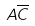Convert formula to latex. <formula><loc_0><loc_0><loc_500><loc_500>A \overline { C }</formula> 